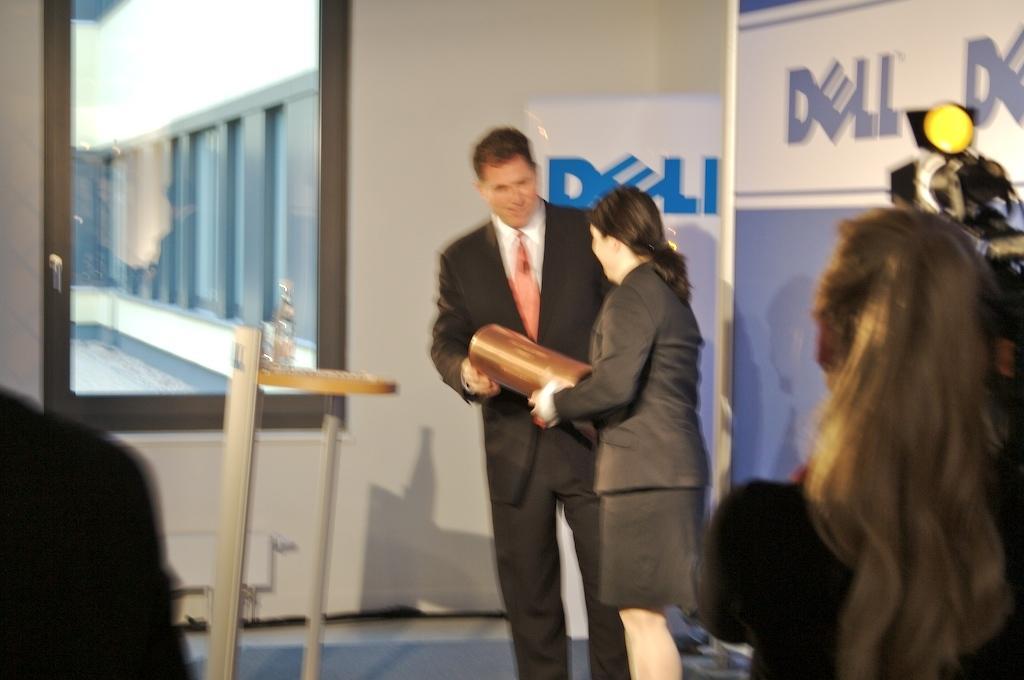Could you give a brief overview of what you see in this image? On the right side of the picture we can see the people. We can see a man and a woman holding an object with their hands. We can see the boards, glass object, window and few objects. 